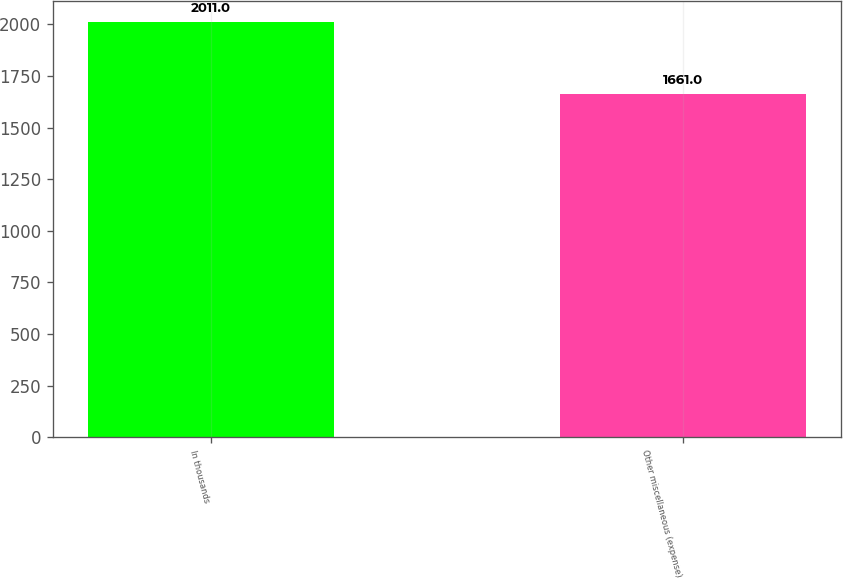<chart> <loc_0><loc_0><loc_500><loc_500><bar_chart><fcel>In thousands<fcel>Other miscellaneous (expense)<nl><fcel>2011<fcel>1661<nl></chart> 